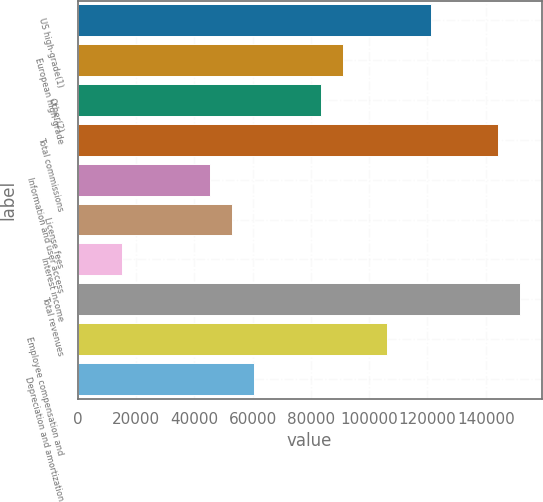Convert chart. <chart><loc_0><loc_0><loc_500><loc_500><bar_chart><fcel>US high-grade(1)<fcel>European high-grade<fcel>Other(2)<fcel>Total commissions<fcel>Information and user access<fcel>License fees<fcel>Interest income<fcel>Total revenues<fcel>Employee compensation and<fcel>Depreciation and amortization<nl><fcel>121274<fcel>90956<fcel>83376.5<fcel>144013<fcel>45478.9<fcel>53058.4<fcel>15160.9<fcel>151592<fcel>106115<fcel>60638<nl></chart> 